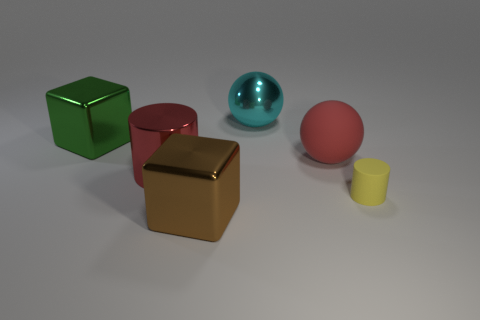Are there more shiny things that are in front of the small cylinder than gray things?
Offer a very short reply. Yes. Is the number of green cubes that are in front of the big red cylinder the same as the number of big red cylinders to the right of the yellow rubber thing?
Provide a short and direct response. Yes. What is the color of the big metallic object that is both behind the big cylinder and right of the large green metallic cube?
Offer a terse response. Cyan. Is there anything else that has the same size as the yellow thing?
Ensure brevity in your answer.  No. Are there more red spheres in front of the cyan thing than cyan metal things that are left of the big brown thing?
Your answer should be very brief. Yes. Do the cylinder to the left of the yellow matte cylinder and the big green block have the same size?
Give a very brief answer. Yes. There is a shiny block left of the big block that is right of the shiny cylinder; what number of large cyan shiny things are to the right of it?
Give a very brief answer. 1. What size is the metal object that is both to the right of the big shiny cylinder and in front of the large metallic sphere?
Your answer should be very brief. Large. How many other things are the same shape as the brown metal object?
Provide a succinct answer. 1. There is a large green cube; how many red matte balls are behind it?
Provide a succinct answer. 0. 